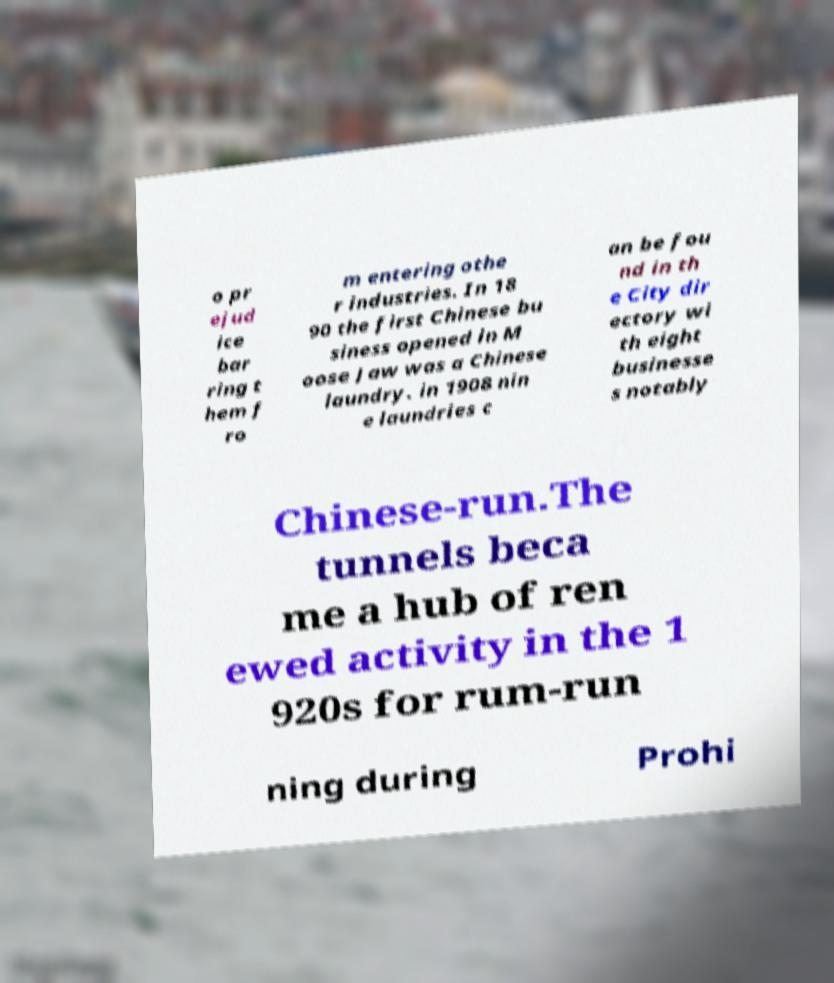Can you accurately transcribe the text from the provided image for me? o pr ejud ice bar ring t hem f ro m entering othe r industries. In 18 90 the first Chinese bu siness opened in M oose Jaw was a Chinese laundry. in 1908 nin e laundries c an be fou nd in th e City dir ectory wi th eight businesse s notably Chinese-run.The tunnels beca me a hub of ren ewed activity in the 1 920s for rum-run ning during Prohi 